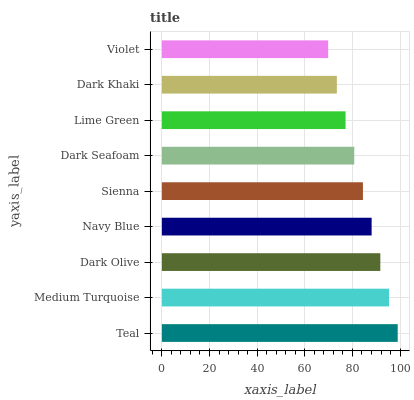Is Violet the minimum?
Answer yes or no. Yes. Is Teal the maximum?
Answer yes or no. Yes. Is Medium Turquoise the minimum?
Answer yes or no. No. Is Medium Turquoise the maximum?
Answer yes or no. No. Is Teal greater than Medium Turquoise?
Answer yes or no. Yes. Is Medium Turquoise less than Teal?
Answer yes or no. Yes. Is Medium Turquoise greater than Teal?
Answer yes or no. No. Is Teal less than Medium Turquoise?
Answer yes or no. No. Is Sienna the high median?
Answer yes or no. Yes. Is Sienna the low median?
Answer yes or no. Yes. Is Dark Olive the high median?
Answer yes or no. No. Is Violet the low median?
Answer yes or no. No. 